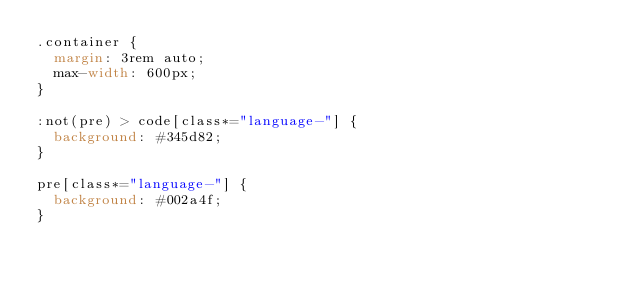<code> <loc_0><loc_0><loc_500><loc_500><_CSS_>.container {
  margin: 3rem auto;
  max-width: 600px;
}

:not(pre) > code[class*="language-"] {
  background: #345d82;
}

pre[class*="language-"] {
  background: #002a4f;
}
</code> 